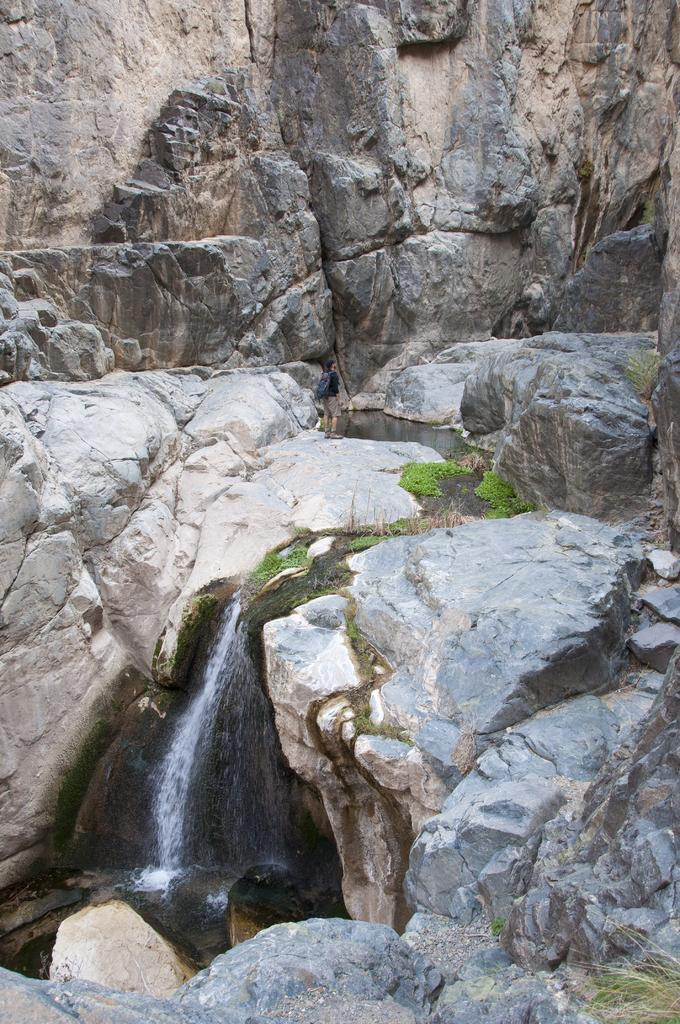What type of natural formation can be seen in the image? There is a waterfall in the image. What other elements are present in the image? There are rocks and grass in the image. What type of ocean waves can be seen in the image? There is no ocean or waves present in the image; it features a waterfall, rocks, and grass. 